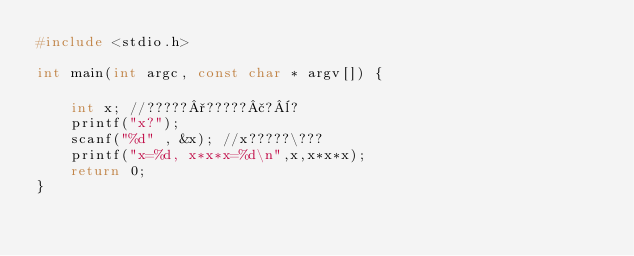Convert code to text. <code><loc_0><loc_0><loc_500><loc_500><_C_>#include <stdio.h>

int main(int argc, const char * argv[]) {
    
    int x; //?????°?????£?¨?
    printf("x?");
    scanf("%d" , &x); //x?????\???
    printf("x=%d, x*x*x=%d\n",x,x*x*x);
    return 0;
}</code> 